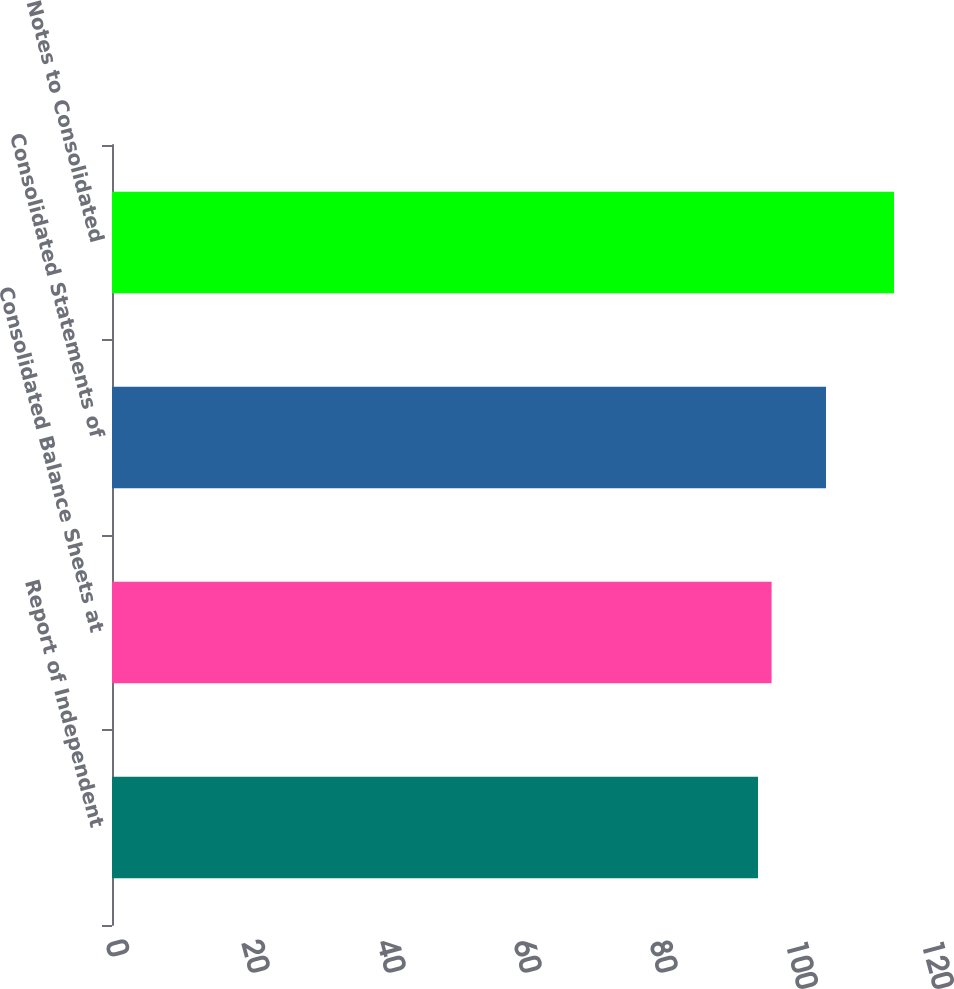Convert chart. <chart><loc_0><loc_0><loc_500><loc_500><bar_chart><fcel>Report of Independent<fcel>Consolidated Balance Sheets at<fcel>Consolidated Statements of<fcel>Notes to Consolidated<nl><fcel>95<fcel>97<fcel>105<fcel>115<nl></chart> 